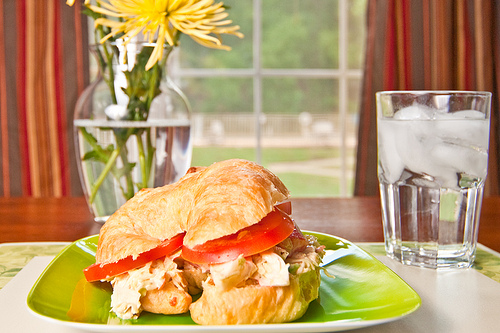On which side of the image is the vase? The vase is positioned on the left side of the image. 